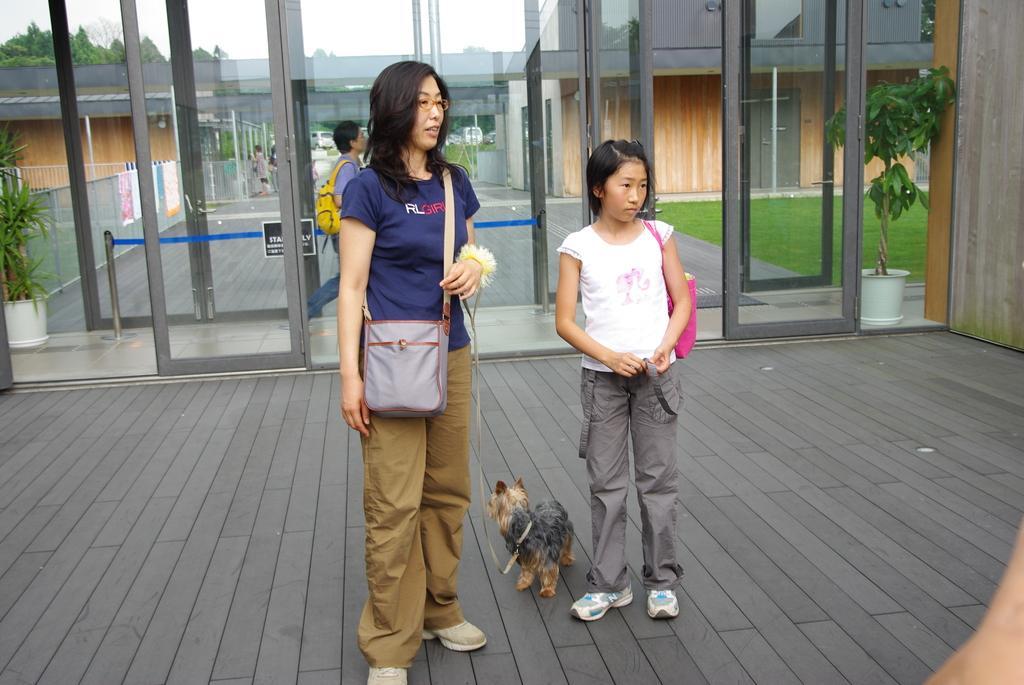Describe this image in one or two sentences. In this picture there is a woman standing in the center and wearing bag. She is wearing leash. Beside her there is another girl wearing a handbag and in between them there is dog. Behind them there are glass doors and a man walking. In the background there are building, trees, sky, grass and houseplants. 